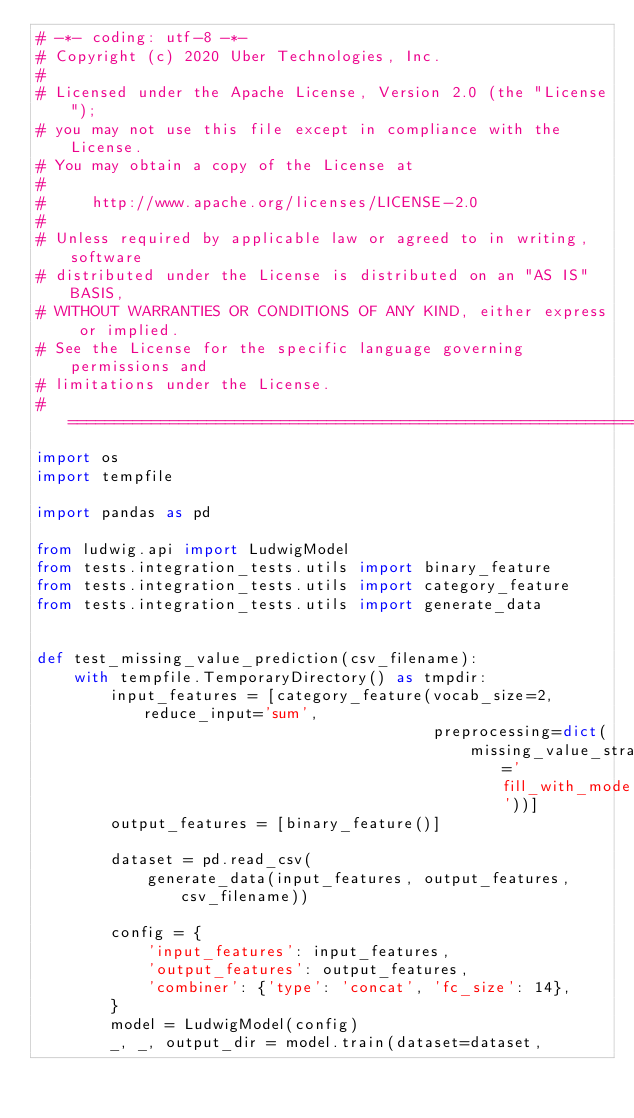<code> <loc_0><loc_0><loc_500><loc_500><_Python_># -*- coding: utf-8 -*-
# Copyright (c) 2020 Uber Technologies, Inc.
#
# Licensed under the Apache License, Version 2.0 (the "License");
# you may not use this file except in compliance with the License.
# You may obtain a copy of the License at
#
#     http://www.apache.org/licenses/LICENSE-2.0
#
# Unless required by applicable law or agreed to in writing, software
# distributed under the License is distributed on an "AS IS" BASIS,
# WITHOUT WARRANTIES OR CONDITIONS OF ANY KIND, either express or implied.
# See the License for the specific language governing permissions and
# limitations under the License.
# ==============================================================================
import os
import tempfile

import pandas as pd

from ludwig.api import LudwigModel
from tests.integration_tests.utils import binary_feature
from tests.integration_tests.utils import category_feature
from tests.integration_tests.utils import generate_data


def test_missing_value_prediction(csv_filename):
    with tempfile.TemporaryDirectory() as tmpdir:
        input_features = [category_feature(vocab_size=2, reduce_input='sum',
                                           preprocessing=dict(
                                               missing_value_strategy='fill_with_mode'))]
        output_features = [binary_feature()]

        dataset = pd.read_csv(
            generate_data(input_features, output_features, csv_filename))

        config = {
            'input_features': input_features,
            'output_features': output_features,
            'combiner': {'type': 'concat', 'fc_size': 14},
        }
        model = LudwigModel(config)
        _, _, output_dir = model.train(dataset=dataset,</code> 